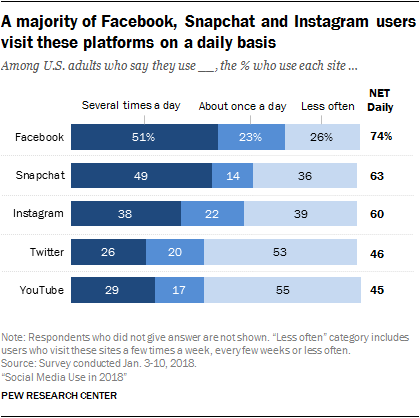Highlight a few significant elements in this photo. In the chart, the percentage of Facebook users who use the platform several times a day is 0.51. YouTube users who watch videos multiple times a day have a higher ratio compared to those who watch less often, with a decimal value of approximately 1.246527778... 